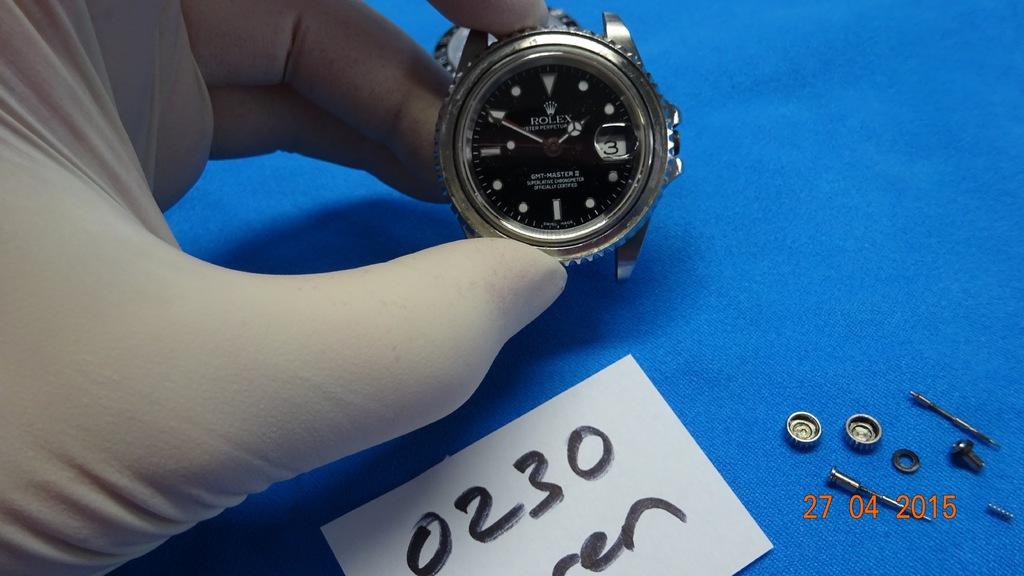What numbers can you see written on the paper?
Offer a very short reply. 0230. 